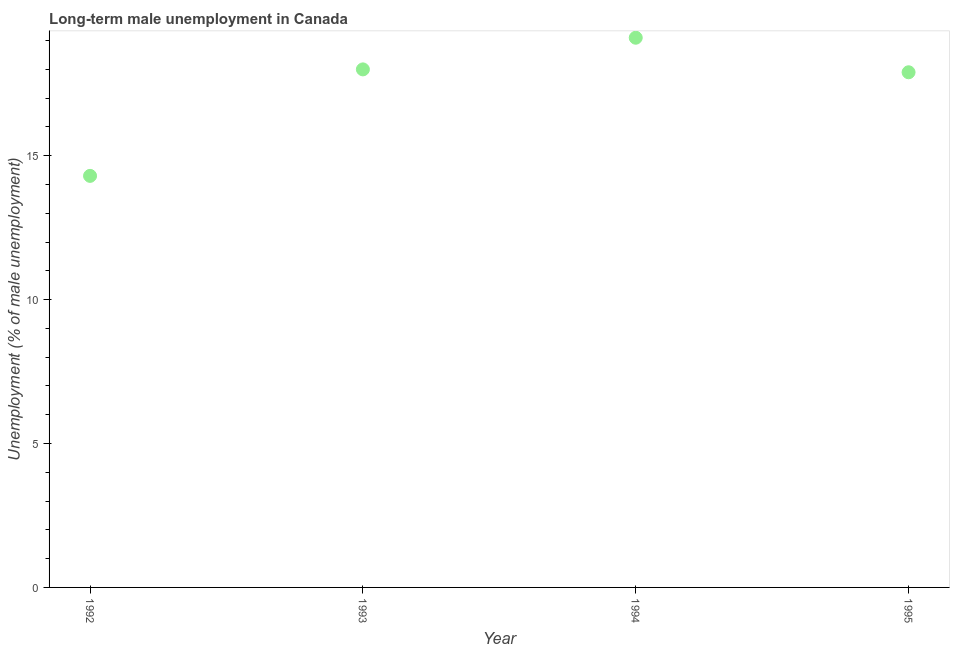What is the long-term male unemployment in 1995?
Make the answer very short. 17.9. Across all years, what is the maximum long-term male unemployment?
Keep it short and to the point. 19.1. Across all years, what is the minimum long-term male unemployment?
Your response must be concise. 14.3. In which year was the long-term male unemployment maximum?
Your answer should be compact. 1994. In which year was the long-term male unemployment minimum?
Your answer should be very brief. 1992. What is the sum of the long-term male unemployment?
Your response must be concise. 69.3. What is the difference between the long-term male unemployment in 1993 and 1995?
Keep it short and to the point. 0.1. What is the average long-term male unemployment per year?
Give a very brief answer. 17.33. What is the median long-term male unemployment?
Provide a short and direct response. 17.95. In how many years, is the long-term male unemployment greater than 13 %?
Your answer should be very brief. 4. Do a majority of the years between 1992 and 1993 (inclusive) have long-term male unemployment greater than 2 %?
Provide a succinct answer. Yes. What is the ratio of the long-term male unemployment in 1994 to that in 1995?
Provide a succinct answer. 1.07. Is the difference between the long-term male unemployment in 1992 and 1994 greater than the difference between any two years?
Keep it short and to the point. Yes. What is the difference between the highest and the second highest long-term male unemployment?
Provide a short and direct response. 1.1. Is the sum of the long-term male unemployment in 1992 and 1995 greater than the maximum long-term male unemployment across all years?
Provide a succinct answer. Yes. What is the difference between the highest and the lowest long-term male unemployment?
Provide a succinct answer. 4.8. Does the long-term male unemployment monotonically increase over the years?
Offer a very short reply. No. How many dotlines are there?
Keep it short and to the point. 1. How many years are there in the graph?
Give a very brief answer. 4. Are the values on the major ticks of Y-axis written in scientific E-notation?
Your answer should be very brief. No. Does the graph contain grids?
Provide a succinct answer. No. What is the title of the graph?
Keep it short and to the point. Long-term male unemployment in Canada. What is the label or title of the Y-axis?
Keep it short and to the point. Unemployment (% of male unemployment). What is the Unemployment (% of male unemployment) in 1992?
Give a very brief answer. 14.3. What is the Unemployment (% of male unemployment) in 1993?
Provide a succinct answer. 18. What is the Unemployment (% of male unemployment) in 1994?
Give a very brief answer. 19.1. What is the Unemployment (% of male unemployment) in 1995?
Offer a very short reply. 17.9. What is the difference between the Unemployment (% of male unemployment) in 1992 and 1994?
Provide a short and direct response. -4.8. What is the difference between the Unemployment (% of male unemployment) in 1992 and 1995?
Provide a succinct answer. -3.6. What is the difference between the Unemployment (% of male unemployment) in 1993 and 1994?
Provide a succinct answer. -1.1. What is the ratio of the Unemployment (% of male unemployment) in 1992 to that in 1993?
Your response must be concise. 0.79. What is the ratio of the Unemployment (% of male unemployment) in 1992 to that in 1994?
Ensure brevity in your answer.  0.75. What is the ratio of the Unemployment (% of male unemployment) in 1992 to that in 1995?
Provide a short and direct response. 0.8. What is the ratio of the Unemployment (% of male unemployment) in 1993 to that in 1994?
Offer a very short reply. 0.94. What is the ratio of the Unemployment (% of male unemployment) in 1993 to that in 1995?
Your answer should be very brief. 1.01. What is the ratio of the Unemployment (% of male unemployment) in 1994 to that in 1995?
Offer a terse response. 1.07. 